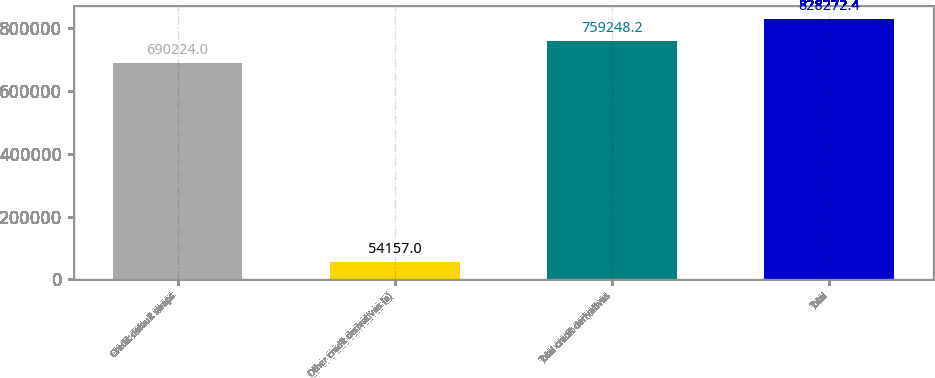Convert chart. <chart><loc_0><loc_0><loc_500><loc_500><bar_chart><fcel>Credit default swaps<fcel>Other credit derivatives (a)<fcel>Total credit derivatives<fcel>Total<nl><fcel>690224<fcel>54157<fcel>759248<fcel>828272<nl></chart> 